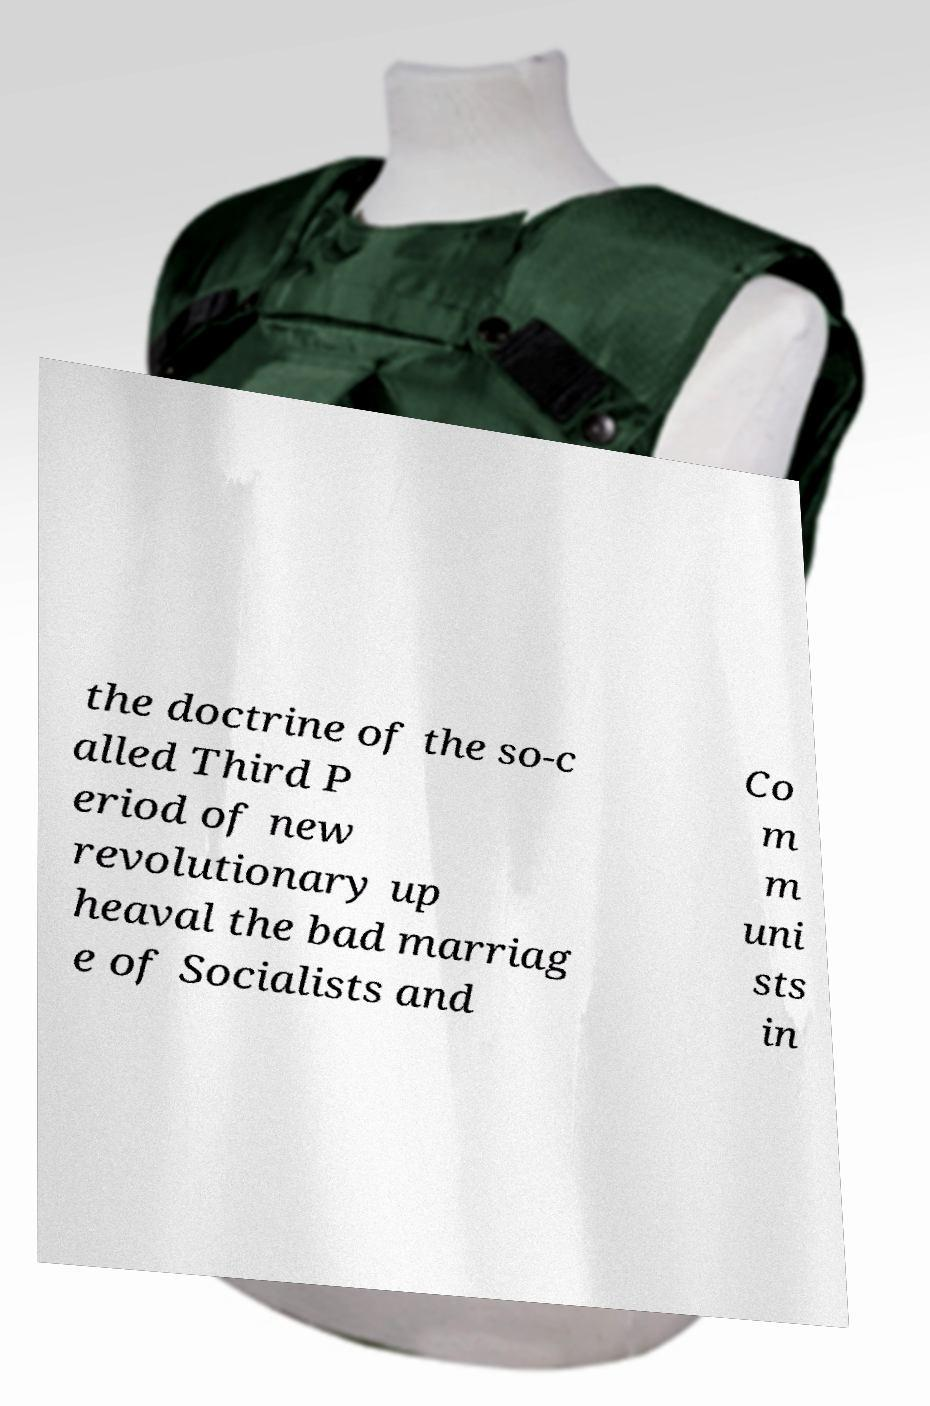Can you accurately transcribe the text from the provided image for me? the doctrine of the so-c alled Third P eriod of new revolutionary up heaval the bad marriag e of Socialists and Co m m uni sts in 